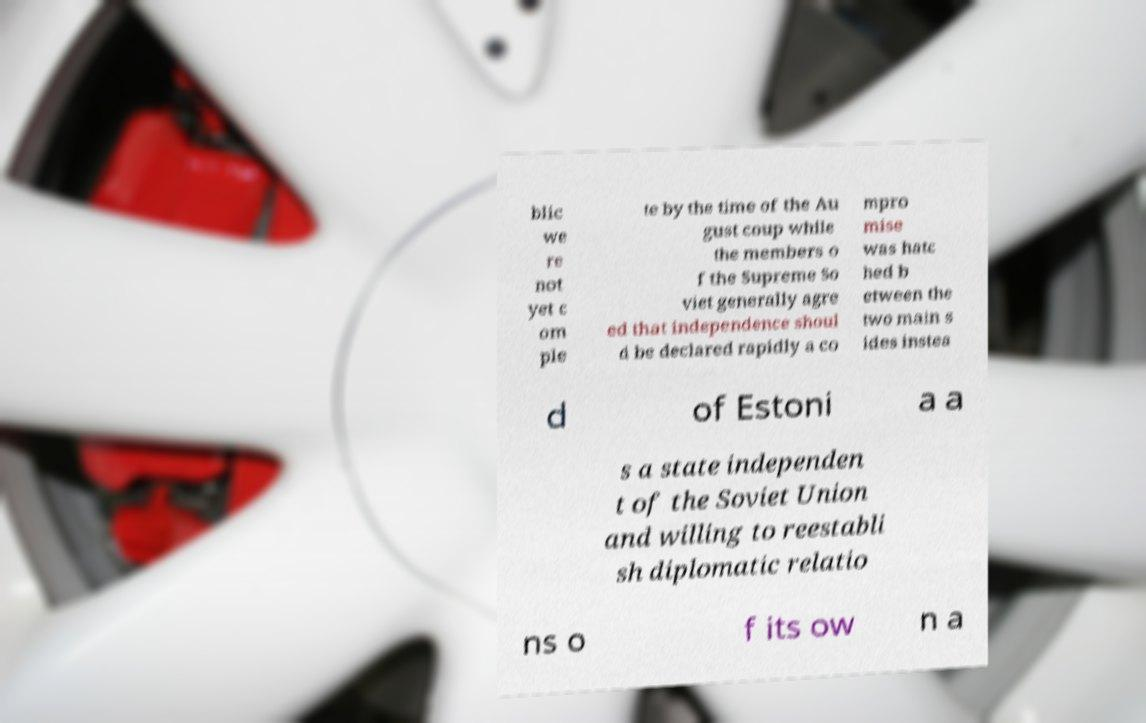Please read and relay the text visible in this image. What does it say? blic we re not yet c om ple te by the time of the Au gust coup while the members o f the Supreme So viet generally agre ed that independence shoul d be declared rapidly a co mpro mise was hatc hed b etween the two main s ides instea d of Estoni a a s a state independen t of the Soviet Union and willing to reestabli sh diplomatic relatio ns o f its ow n a 